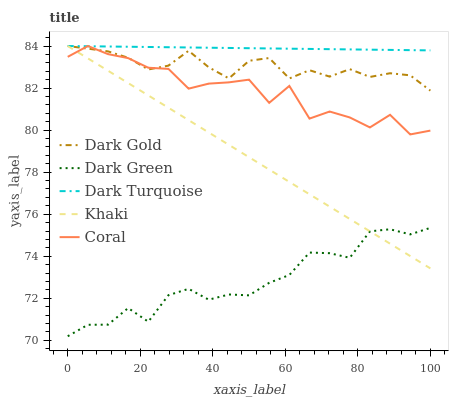Does Dark Green have the minimum area under the curve?
Answer yes or no. Yes. Does Dark Turquoise have the maximum area under the curve?
Answer yes or no. Yes. Does Coral have the minimum area under the curve?
Answer yes or no. No. Does Coral have the maximum area under the curve?
Answer yes or no. No. Is Khaki the smoothest?
Answer yes or no. Yes. Is Coral the roughest?
Answer yes or no. Yes. Is Dark Green the smoothest?
Answer yes or no. No. Is Dark Green the roughest?
Answer yes or no. No. Does Dark Green have the lowest value?
Answer yes or no. Yes. Does Coral have the lowest value?
Answer yes or no. No. Does Dark Gold have the highest value?
Answer yes or no. Yes. Does Dark Green have the highest value?
Answer yes or no. No. Is Dark Green less than Dark Gold?
Answer yes or no. Yes. Is Coral greater than Dark Green?
Answer yes or no. Yes. Does Khaki intersect Dark Turquoise?
Answer yes or no. Yes. Is Khaki less than Dark Turquoise?
Answer yes or no. No. Is Khaki greater than Dark Turquoise?
Answer yes or no. No. Does Dark Green intersect Dark Gold?
Answer yes or no. No. 